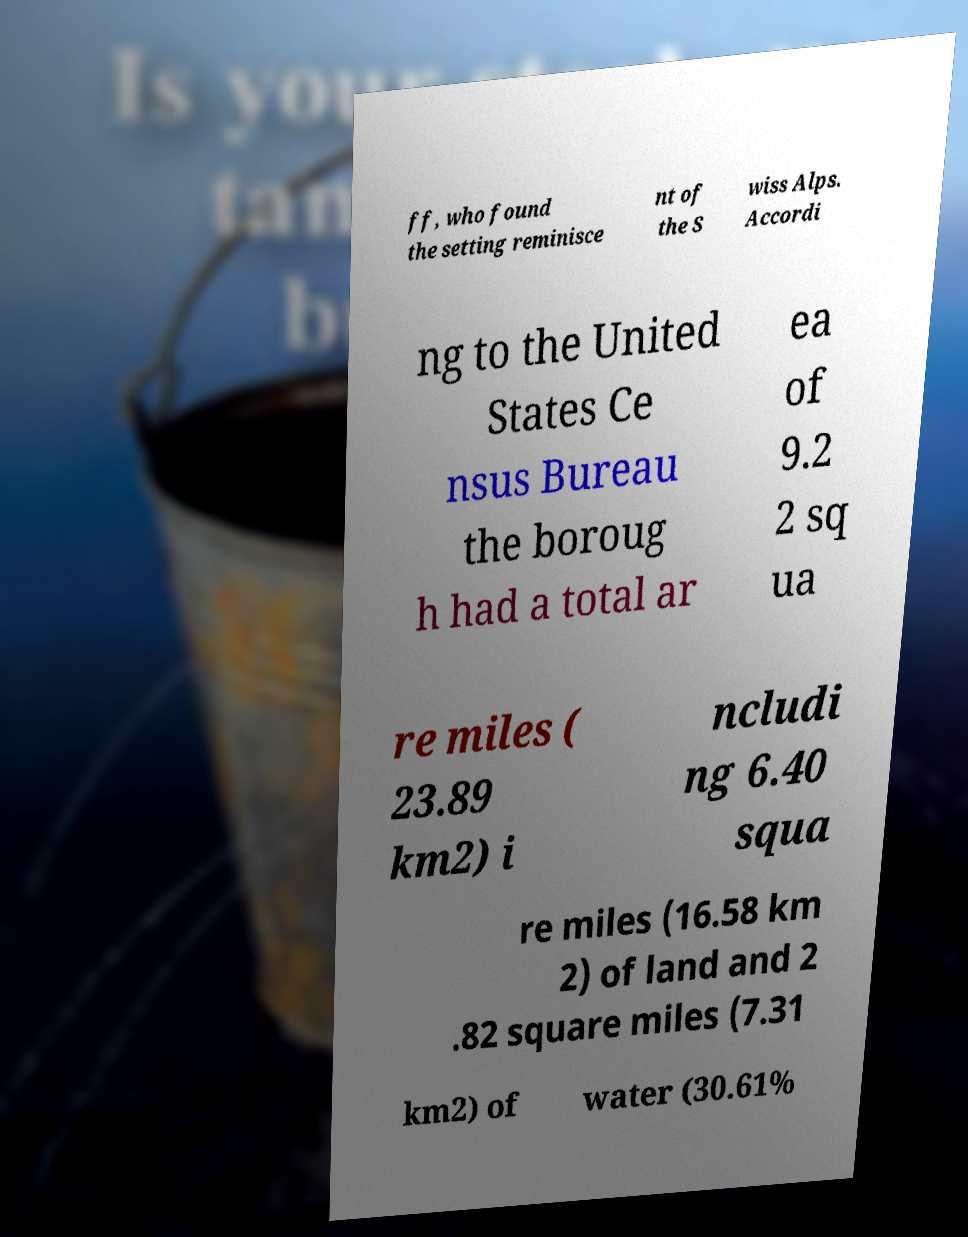Can you read and provide the text displayed in the image?This photo seems to have some interesting text. Can you extract and type it out for me? ff, who found the setting reminisce nt of the S wiss Alps. Accordi ng to the United States Ce nsus Bureau the boroug h had a total ar ea of 9.2 2 sq ua re miles ( 23.89 km2) i ncludi ng 6.40 squa re miles (16.58 km 2) of land and 2 .82 square miles (7.31 km2) of water (30.61% 